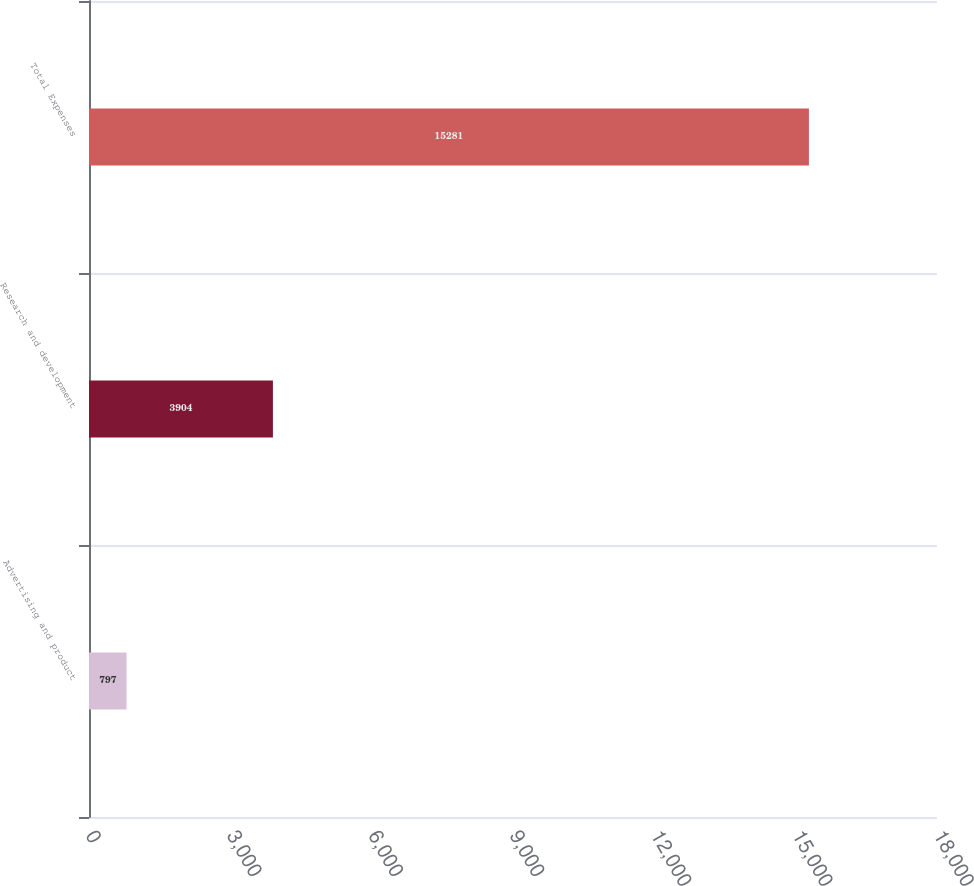Convert chart to OTSL. <chart><loc_0><loc_0><loc_500><loc_500><bar_chart><fcel>Advertising and product<fcel>Research and development<fcel>Total Expenses<nl><fcel>797<fcel>3904<fcel>15281<nl></chart> 